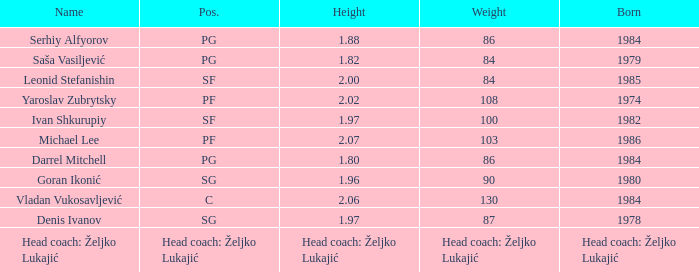What is the ranking of the 1.80m tall player who was born in 1984? PG. 